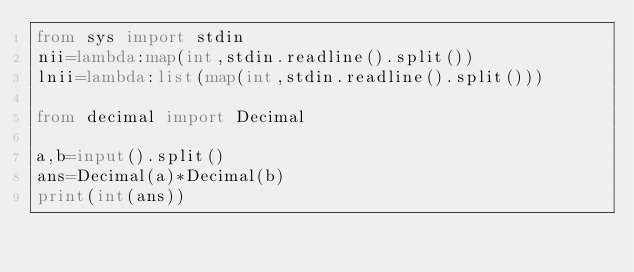<code> <loc_0><loc_0><loc_500><loc_500><_Python_>from sys import stdin
nii=lambda:map(int,stdin.readline().split())
lnii=lambda:list(map(int,stdin.readline().split()))

from decimal import Decimal

a,b=input().split()
ans=Decimal(a)*Decimal(b)
print(int(ans))</code> 